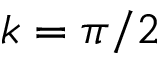Convert formula to latex. <formula><loc_0><loc_0><loc_500><loc_500>k = \pi / 2</formula> 